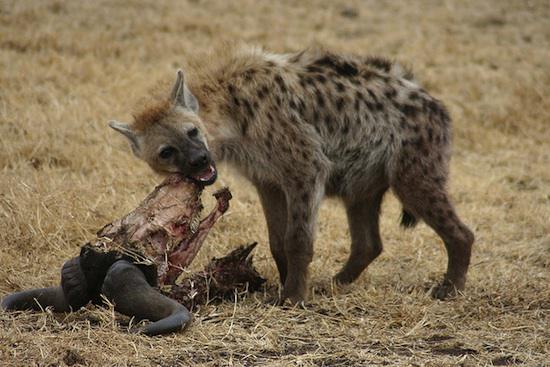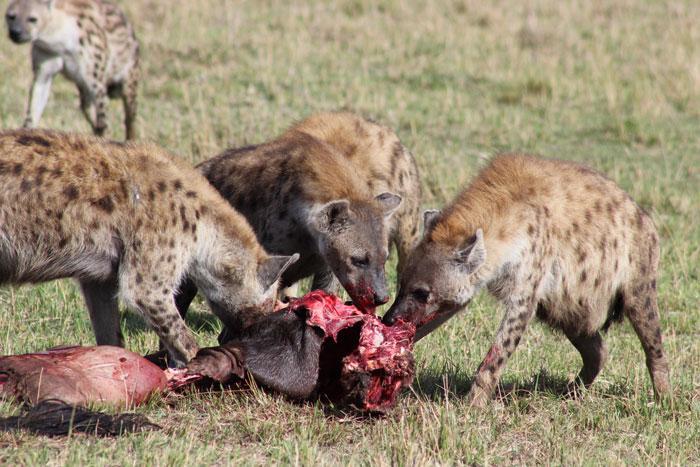The first image is the image on the left, the second image is the image on the right. Considering the images on both sides, is "An elephant with tusks is running near a hyena." valid? Answer yes or no. No. The first image is the image on the left, the second image is the image on the right. Given the left and right images, does the statement "There is an elephant among hyenas in one of the images." hold true? Answer yes or no. No. 